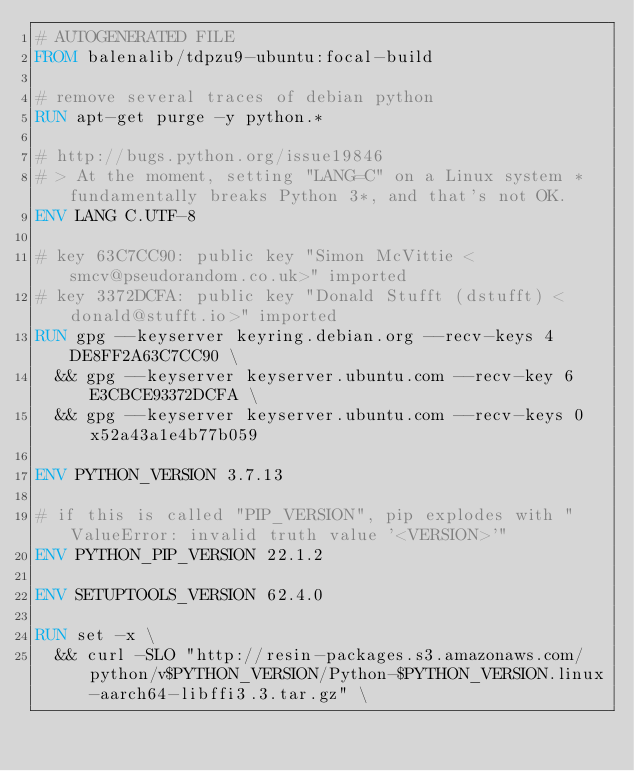<code> <loc_0><loc_0><loc_500><loc_500><_Dockerfile_># AUTOGENERATED FILE
FROM balenalib/tdpzu9-ubuntu:focal-build

# remove several traces of debian python
RUN apt-get purge -y python.*

# http://bugs.python.org/issue19846
# > At the moment, setting "LANG=C" on a Linux system *fundamentally breaks Python 3*, and that's not OK.
ENV LANG C.UTF-8

# key 63C7CC90: public key "Simon McVittie <smcv@pseudorandom.co.uk>" imported
# key 3372DCFA: public key "Donald Stufft (dstufft) <donald@stufft.io>" imported
RUN gpg --keyserver keyring.debian.org --recv-keys 4DE8FF2A63C7CC90 \
	&& gpg --keyserver keyserver.ubuntu.com --recv-key 6E3CBCE93372DCFA \
	&& gpg --keyserver keyserver.ubuntu.com --recv-keys 0x52a43a1e4b77b059

ENV PYTHON_VERSION 3.7.13

# if this is called "PIP_VERSION", pip explodes with "ValueError: invalid truth value '<VERSION>'"
ENV PYTHON_PIP_VERSION 22.1.2

ENV SETUPTOOLS_VERSION 62.4.0

RUN set -x \
	&& curl -SLO "http://resin-packages.s3.amazonaws.com/python/v$PYTHON_VERSION/Python-$PYTHON_VERSION.linux-aarch64-libffi3.3.tar.gz" \</code> 